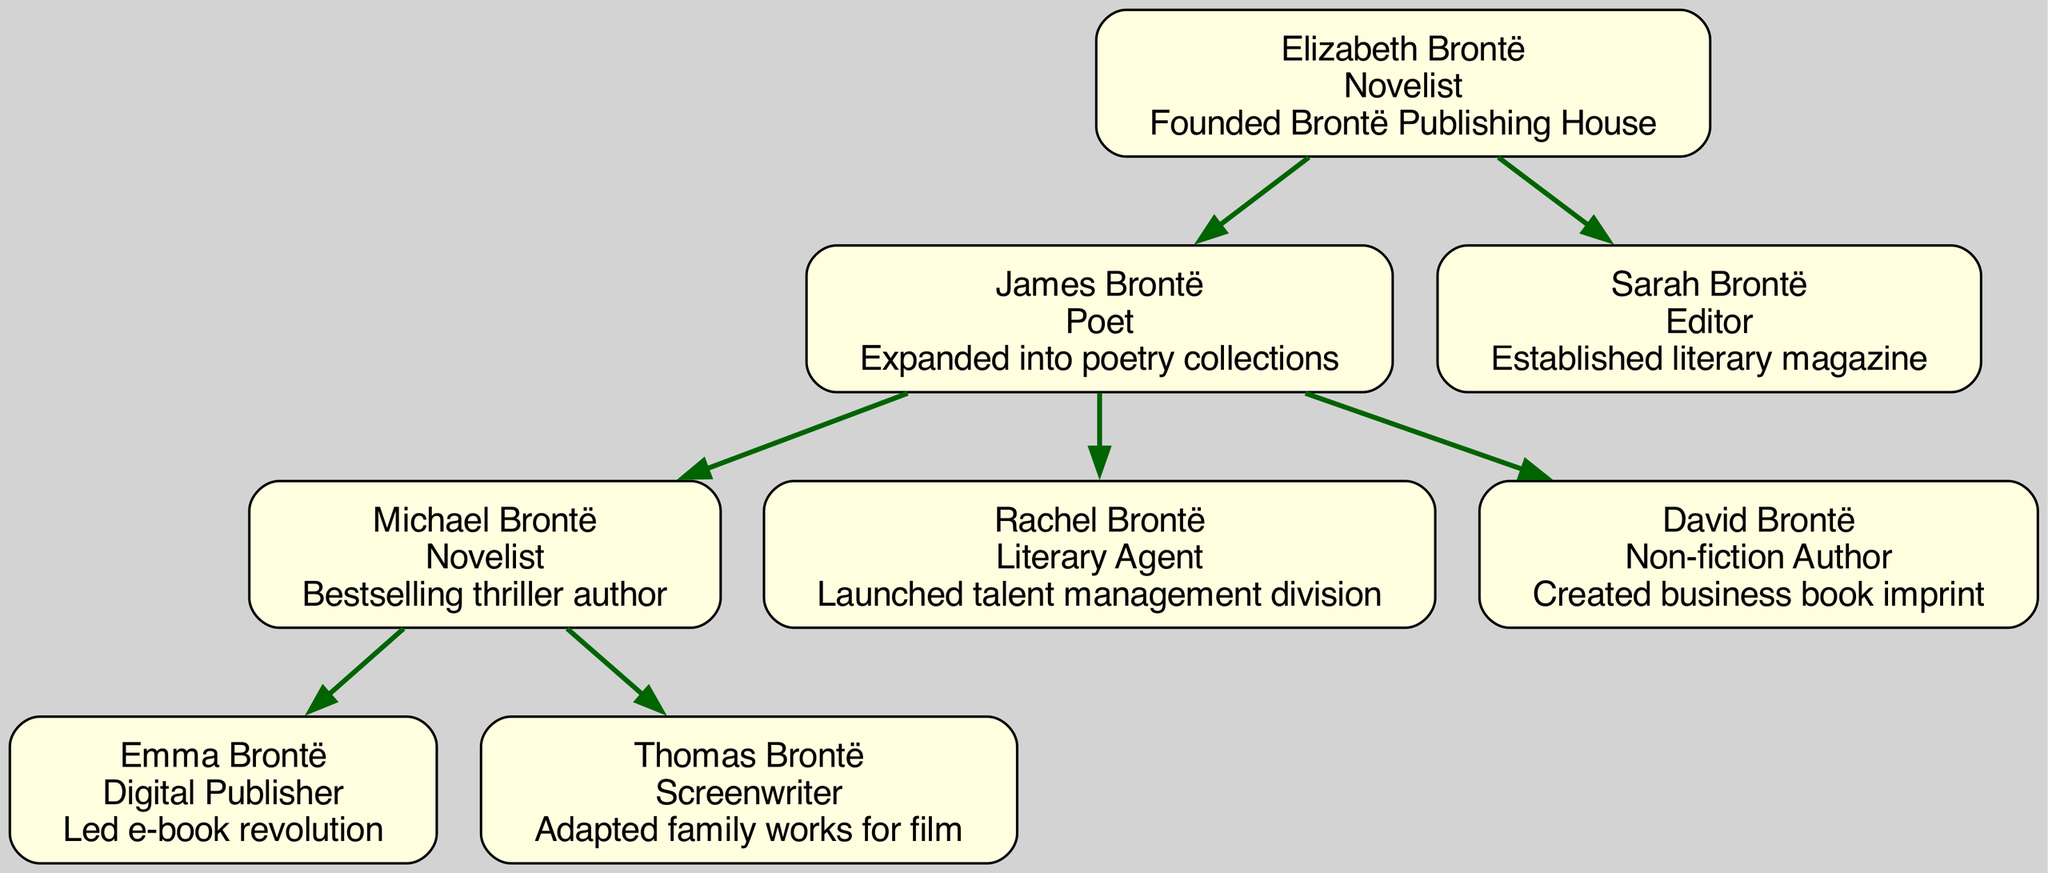What is the profession of Elizabeth Brontë? The diagram shows Elizabeth Brontë connected to her role at the root. Her profession is listed as "Novelist."
Answer: Novelist How many children did Elizabeth Brontë have? The diagram indicates a branch from Elizabeth Brontë with two nodes representing her children, James Brontë and Sarah Brontë.
Answer: 2 Who is the literary agent among the grandchildren? By examining the grandchildren nodes, Rachel Brontë is explicitly labeled as a "Literary Agent," which identifies her profession.
Answer: Rachel Brontë What is the contribution of David Brontë? The diagram lists David Brontë's contributions within his node, stating he "Created business book imprint."
Answer: Created business book imprint Which profession does Emma Brontë hold? Emma Brontë is in the great-grandchildren section, and her node clearly lists her profession as "Digital Publisher."
Answer: Digital Publisher Who is the poet in the family? James Brontë, shown among the children, has his profession labeled as "Poet," making him the specified member with that title.
Answer: James Brontë Which generation did the talent management division get launched? The contribution of Rachel Brontë, a grandchild, detailing her launch of a "talent management division," indicates this occurred in the grandchild generation.
Answer: Grandchild generation How many great-grandchildren are there? The diagram lists two nodes under the great-grandchildren section: Emma Brontë and Thomas Brontë, indicating a total count of two.
Answer: 2 Who adapted family works for film? The great-grandchildren node for Thomas Brontë specifies that he "Adapted family works for film," confirming his contribution.
Answer: Thomas Brontë 